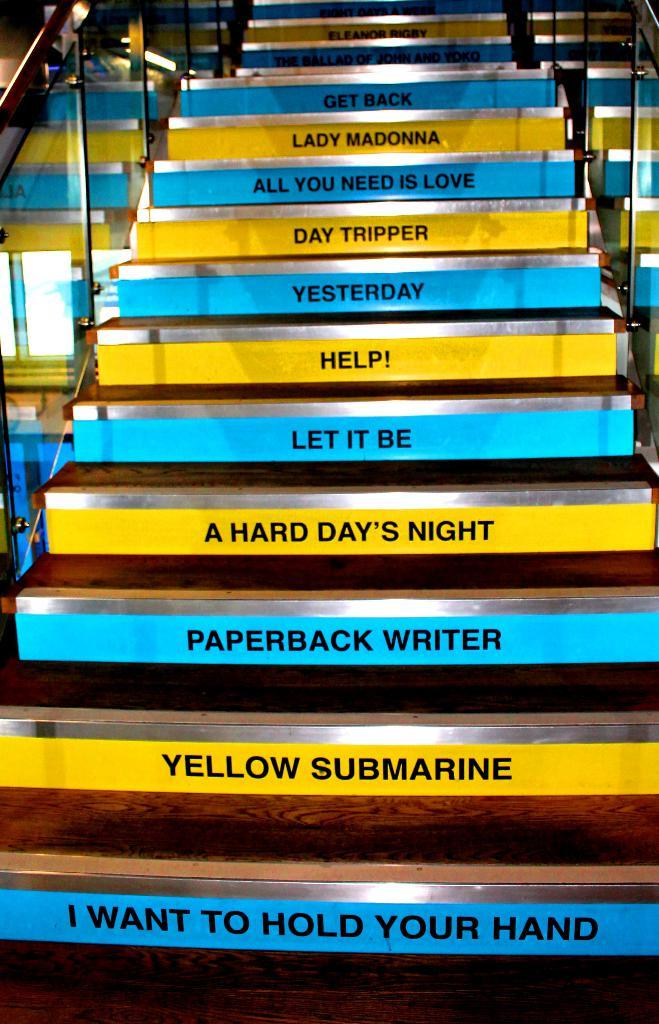<image>
Describe the image concisely. A list of songs in blue and yellow includes Let It Be and Yellow Submarine. 